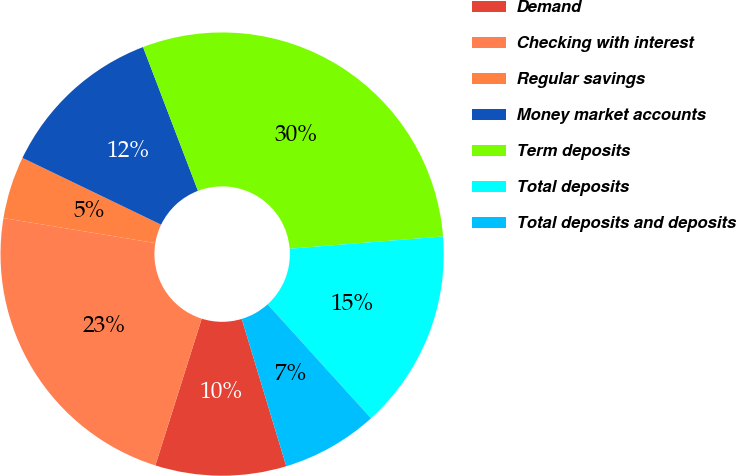Convert chart to OTSL. <chart><loc_0><loc_0><loc_500><loc_500><pie_chart><fcel>Demand<fcel>Checking with interest<fcel>Regular savings<fcel>Money market accounts<fcel>Term deposits<fcel>Total deposits<fcel>Total deposits and deposits<nl><fcel>9.55%<fcel>22.73%<fcel>4.55%<fcel>12.05%<fcel>29.55%<fcel>14.55%<fcel>7.05%<nl></chart> 